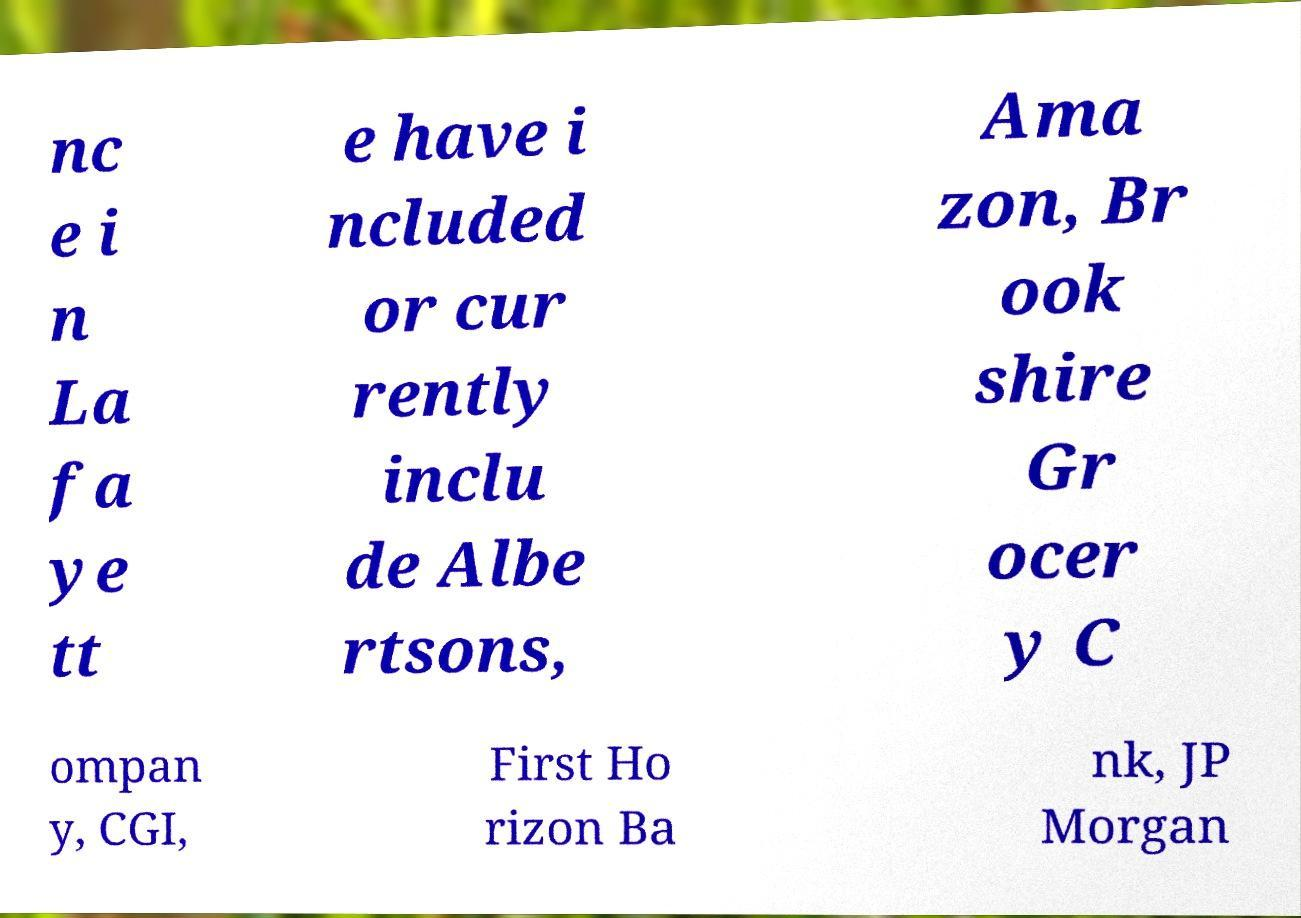For documentation purposes, I need the text within this image transcribed. Could you provide that? nc e i n La fa ye tt e have i ncluded or cur rently inclu de Albe rtsons, Ama zon, Br ook shire Gr ocer y C ompan y, CGI, First Ho rizon Ba nk, JP Morgan 